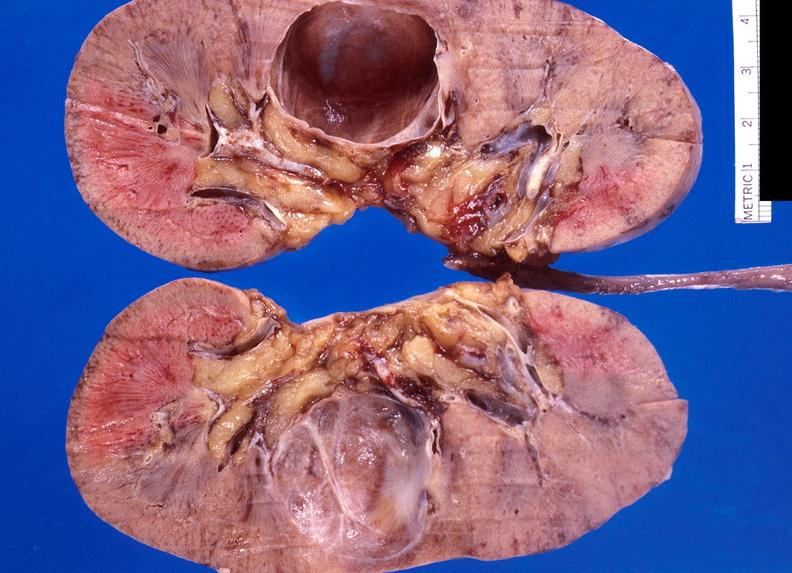does metastatic carcinoma lung show renal cyst?
Answer the question using a single word or phrase. No 